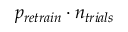Convert formula to latex. <formula><loc_0><loc_0><loc_500><loc_500>p _ { r e t r a i n } \cdot n _ { t r i a l s }</formula> 